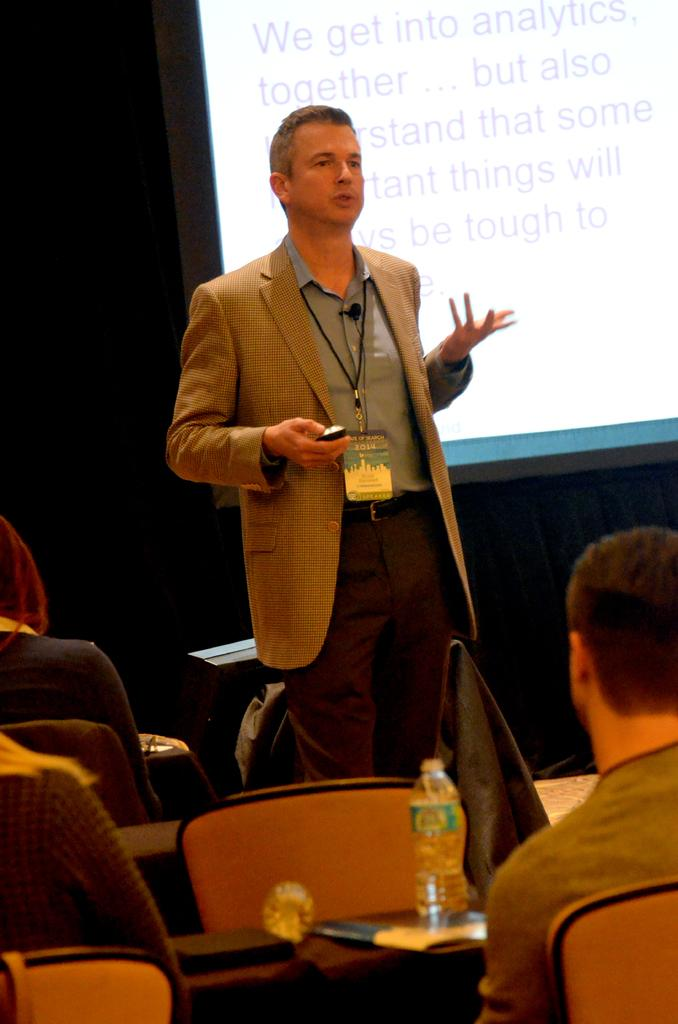What is the main object in the image? There is a screen in the image. Who is present in the image? A man is standing in the image, and there are people sitting in chairs. What furniture is visible in the image? There is a table in the image. What is on the table in the image? There is a bottle on the table in the image. What type of berry is being sold by the beggar in the image? There is no beggar or berry present in the image. 